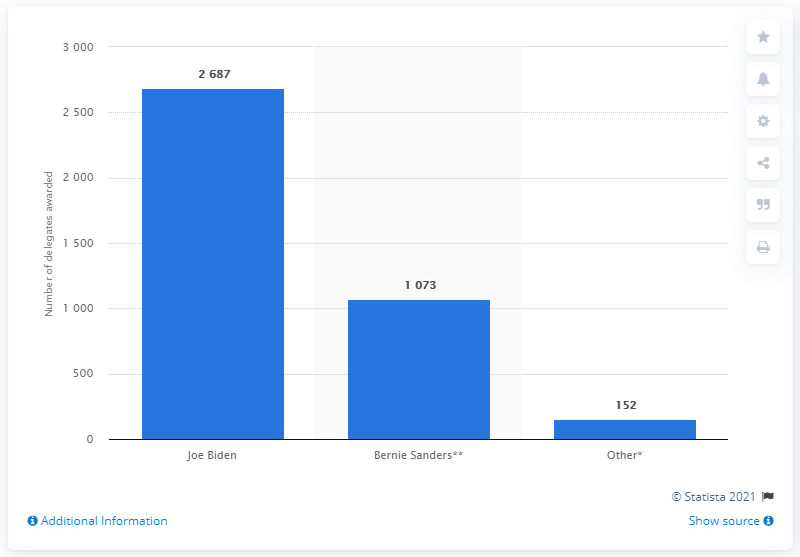Highlight a few significant elements in this photo. It is true that Joe Biden, who served as the Vice President of the United States, had enough delegates to become the Democratic Party's nominee for President of the United States. 